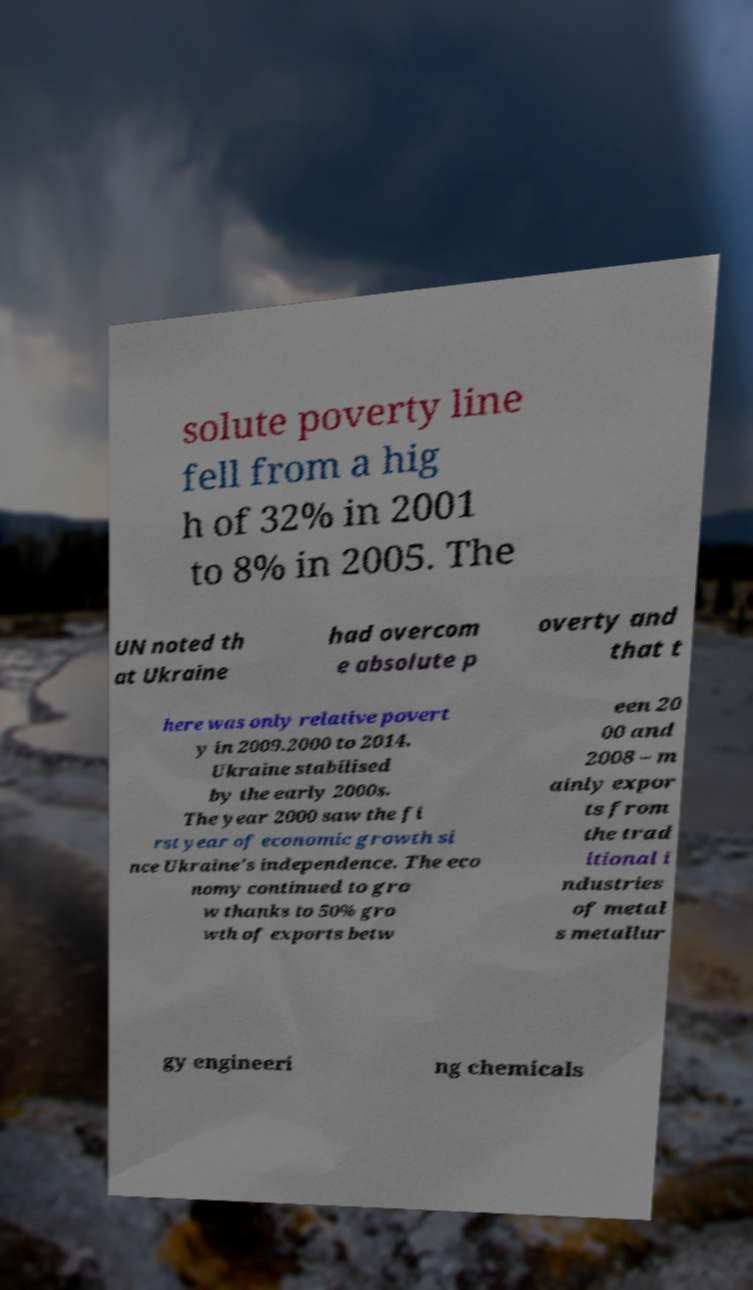Could you extract and type out the text from this image? solute poverty line fell from a hig h of 32% in 2001 to 8% in 2005. The UN noted th at Ukraine had overcom e absolute p overty and that t here was only relative povert y in 2009.2000 to 2014. Ukraine stabilised by the early 2000s. The year 2000 saw the fi rst year of economic growth si nce Ukraine's independence. The eco nomy continued to gro w thanks to 50% gro wth of exports betw een 20 00 and 2008 – m ainly expor ts from the trad itional i ndustries of metal s metallur gy engineeri ng chemicals 